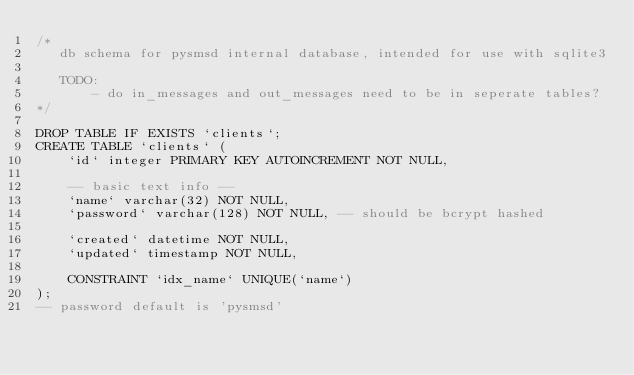Convert code to text. <code><loc_0><loc_0><loc_500><loc_500><_SQL_>/*
   db schema for pysmsd internal database, intended for use with sqlite3

   TODO:
       - do in_messages and out_messages need to be in seperate tables?
*/

DROP TABLE IF EXISTS `clients`;
CREATE TABLE `clients` (
    `id` integer PRIMARY KEY AUTOINCREMENT NOT NULL,

    -- basic text info --
    `name` varchar(32) NOT NULL,
    `password` varchar(128) NOT NULL, -- should be bcrypt hashed

    `created` datetime NOT NULL,
    `updated` timestamp NOT NULL,

    CONSTRAINT `idx_name` UNIQUE(`name`)
);
-- password default is 'pysmsd'</code> 